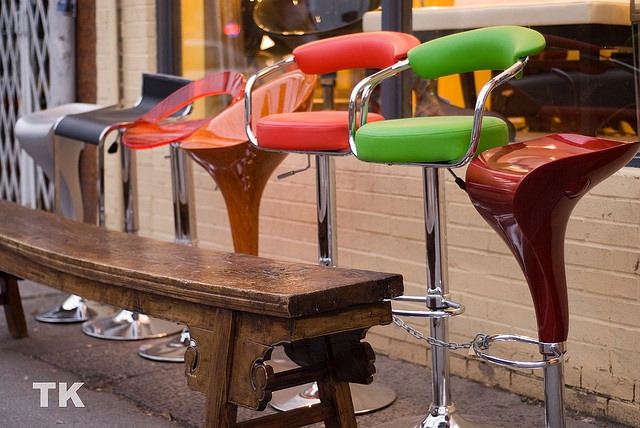Describe the objects in this image and their specific colors. I can see bench in black, maroon, and gray tones, chair in black, gray, and green tones, chair in black, maroon, gray, and brown tones, chair in black, brown, and salmon tones, and chair in black, maroon, salmon, and red tones in this image. 